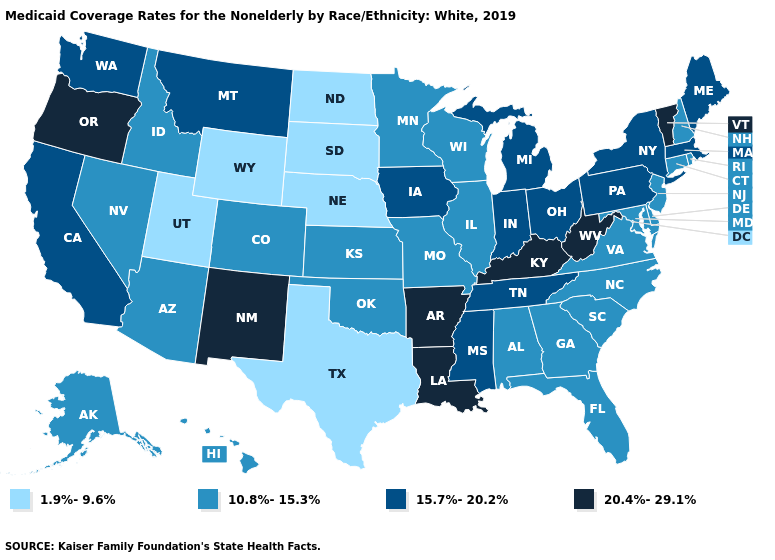Name the states that have a value in the range 20.4%-29.1%?
Concise answer only. Arkansas, Kentucky, Louisiana, New Mexico, Oregon, Vermont, West Virginia. Name the states that have a value in the range 1.9%-9.6%?
Give a very brief answer. Nebraska, North Dakota, South Dakota, Texas, Utah, Wyoming. Which states have the highest value in the USA?
Give a very brief answer. Arkansas, Kentucky, Louisiana, New Mexico, Oregon, Vermont, West Virginia. Among the states that border Louisiana , which have the highest value?
Short answer required. Arkansas. What is the value of Tennessee?
Concise answer only. 15.7%-20.2%. Name the states that have a value in the range 20.4%-29.1%?
Short answer required. Arkansas, Kentucky, Louisiana, New Mexico, Oregon, Vermont, West Virginia. Is the legend a continuous bar?
Quick response, please. No. Among the states that border Texas , which have the highest value?
Short answer required. Arkansas, Louisiana, New Mexico. What is the highest value in the MidWest ?
Short answer required. 15.7%-20.2%. What is the lowest value in the Northeast?
Keep it brief. 10.8%-15.3%. What is the highest value in the West ?
Answer briefly. 20.4%-29.1%. Does Massachusetts have the lowest value in the USA?
Keep it brief. No. Does the map have missing data?
Short answer required. No. Does North Carolina have the highest value in the South?
Keep it brief. No. Among the states that border Idaho , does Utah have the highest value?
Write a very short answer. No. 